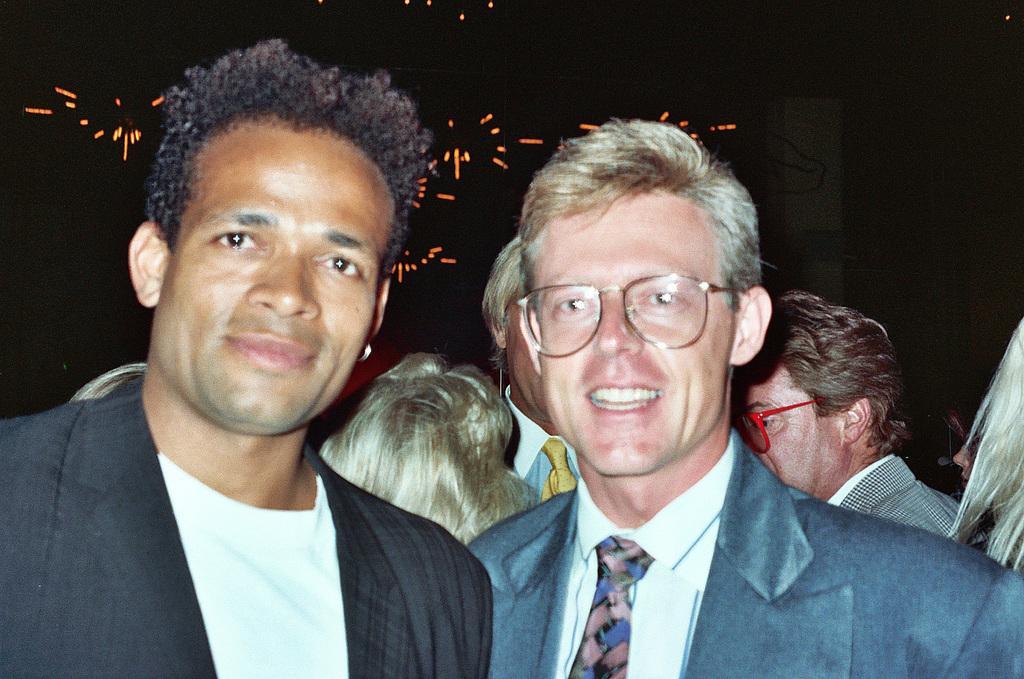Can you describe this image briefly? In this image, we can see many people and in the background, there are lights. 